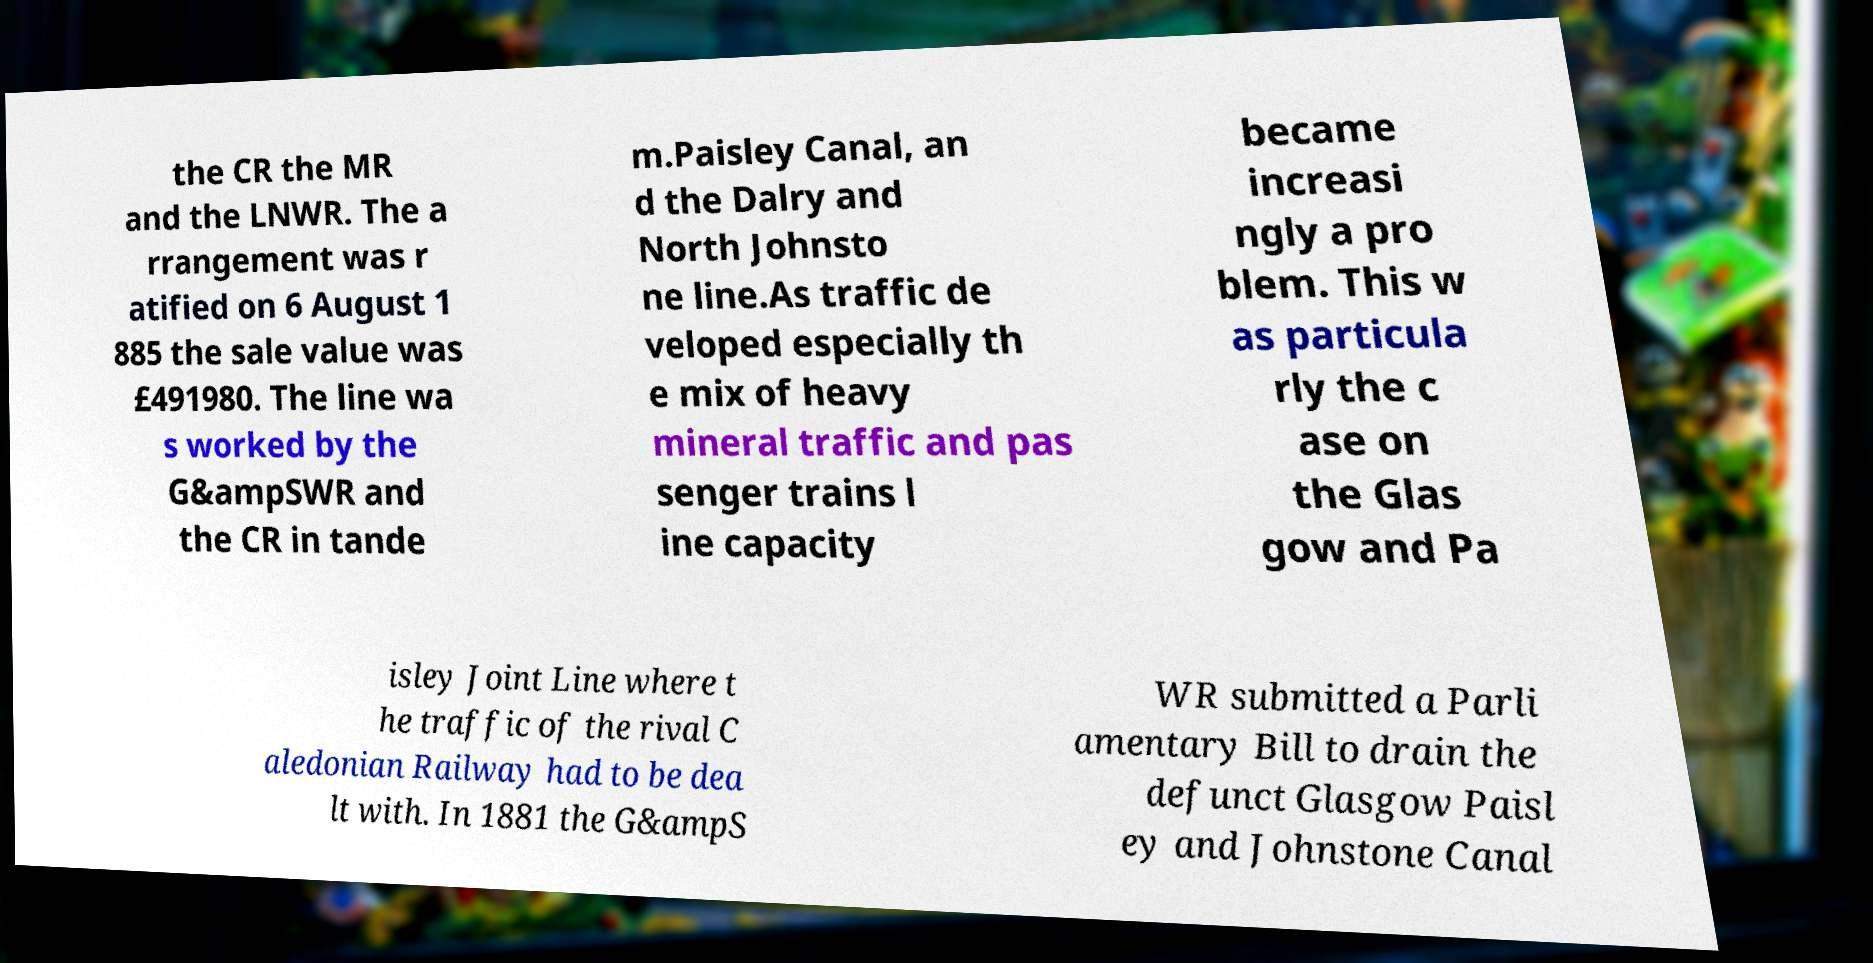For documentation purposes, I need the text within this image transcribed. Could you provide that? the CR the MR and the LNWR. The a rrangement was r atified on 6 August 1 885 the sale value was £491980. The line wa s worked by the G&ampSWR and the CR in tande m.Paisley Canal, an d the Dalry and North Johnsto ne line.As traffic de veloped especially th e mix of heavy mineral traffic and pas senger trains l ine capacity became increasi ngly a pro blem. This w as particula rly the c ase on the Glas gow and Pa isley Joint Line where t he traffic of the rival C aledonian Railway had to be dea lt with. In 1881 the G&ampS WR submitted a Parli amentary Bill to drain the defunct Glasgow Paisl ey and Johnstone Canal 